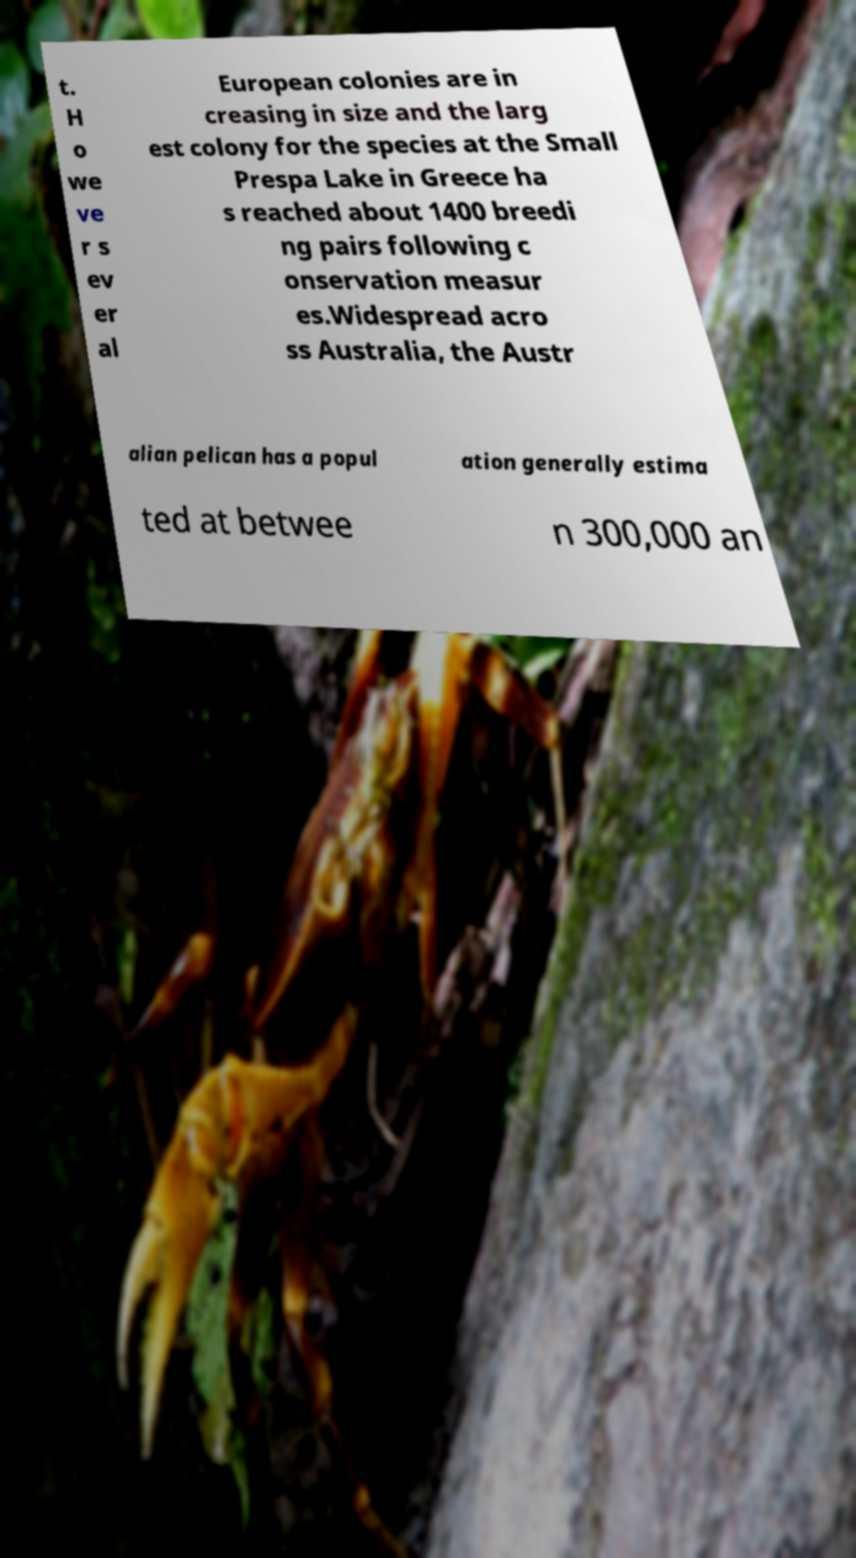Please identify and transcribe the text found in this image. t. H o we ve r s ev er al European colonies are in creasing in size and the larg est colony for the species at the Small Prespa Lake in Greece ha s reached about 1400 breedi ng pairs following c onservation measur es.Widespread acro ss Australia, the Austr alian pelican has a popul ation generally estima ted at betwee n 300,000 an 